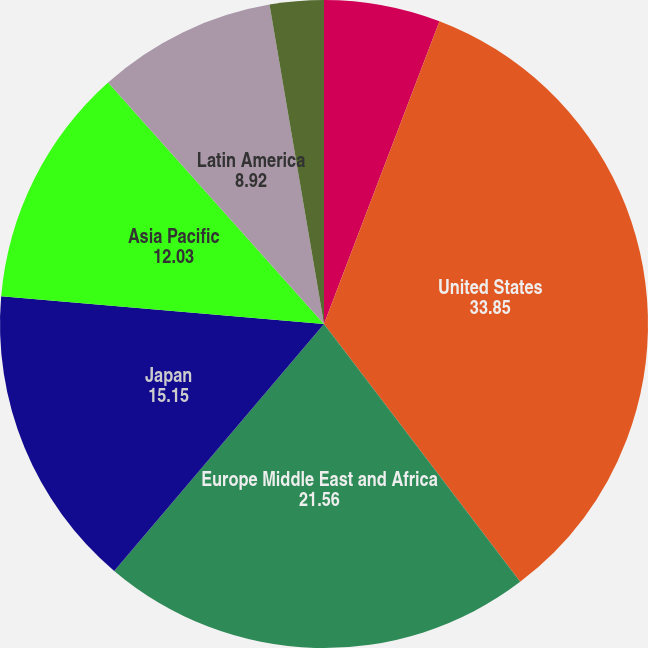Convert chart to OTSL. <chart><loc_0><loc_0><loc_500><loc_500><pie_chart><fcel>Years Ended December 31<fcel>United States<fcel>Europe Middle East and Africa<fcel>Japan<fcel>Asia Pacific<fcel>Latin America<fcel>Other<nl><fcel>5.8%<fcel>33.85%<fcel>21.56%<fcel>15.15%<fcel>12.03%<fcel>8.92%<fcel>2.69%<nl></chart> 